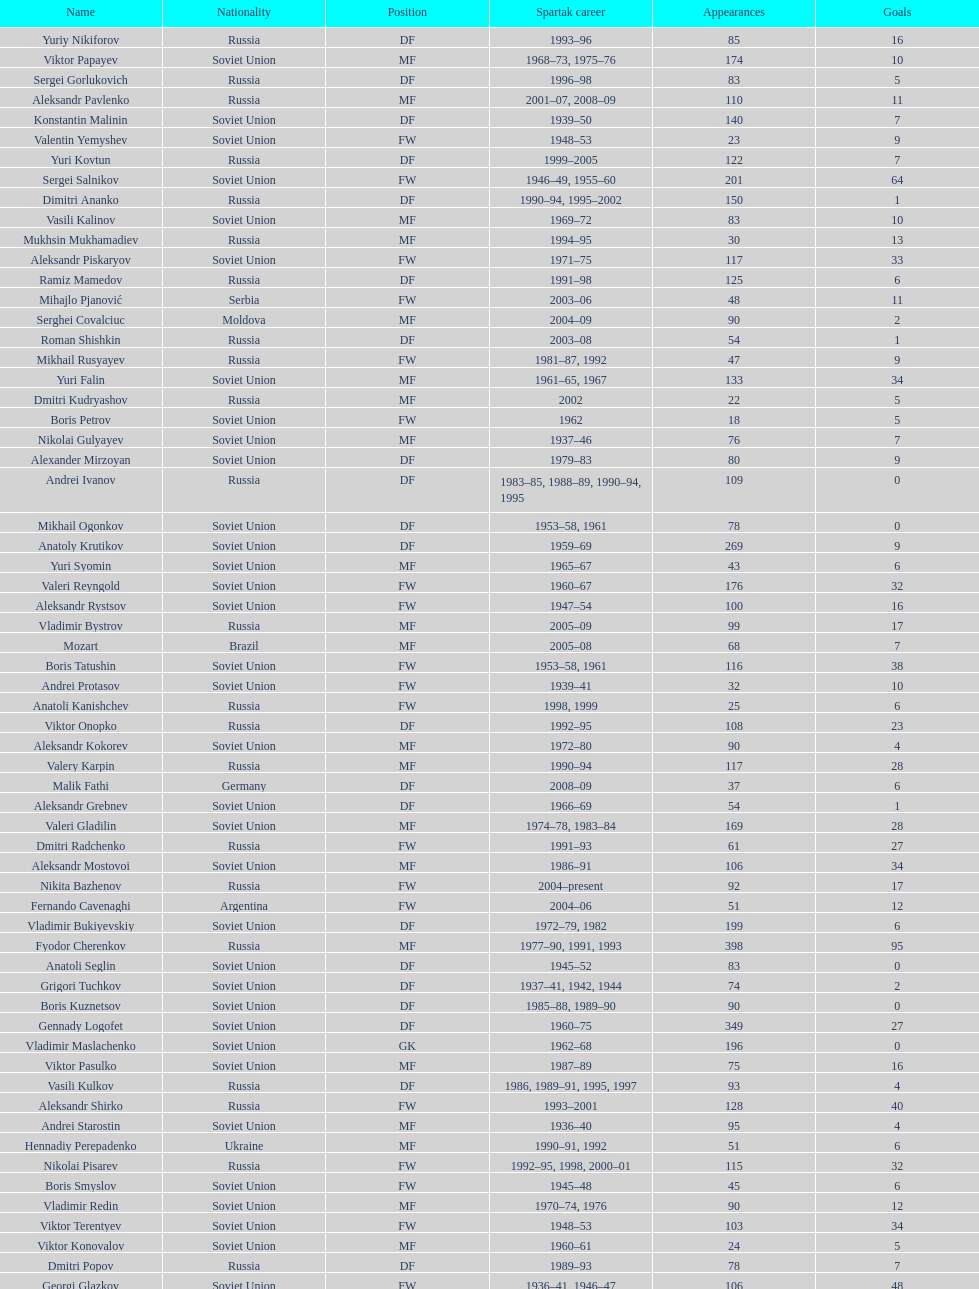Vladimir bukiyevskiy had how many appearances? 199. 